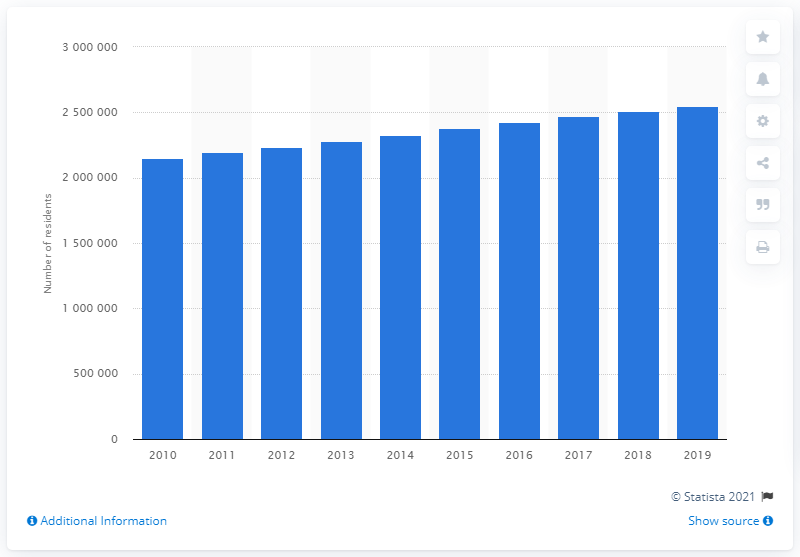Identify some key points in this picture. In 2019, an estimated 2,550,960 individuals lived in the San Antonio-New Braunfels metropolitan area. 